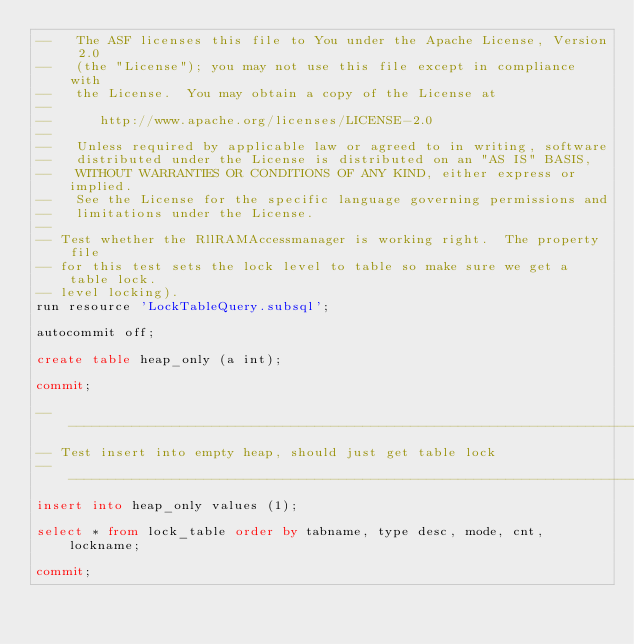Convert code to text. <code><loc_0><loc_0><loc_500><loc_500><_SQL_>--   The ASF licenses this file to You under the Apache License, Version 2.0
--   (the "License"); you may not use this file except in compliance with
--   the License.  You may obtain a copy of the License at
--
--      http://www.apache.org/licenses/LICENSE-2.0
--
--   Unless required by applicable law or agreed to in writing, software
--   distributed under the License is distributed on an "AS IS" BASIS,
--   WITHOUT WARRANTIES OR CONDITIONS OF ANY KIND, either express or implied.
--   See the License for the specific language governing permissions and
--   limitations under the License.
--
-- Test whether the RllRAMAccessmanager is working right.  The property file
-- for this test sets the lock level to table so make sure we get a table lock.
-- level locking). 
run resource 'LockTableQuery.subsql';

autocommit off;

create table heap_only (a int);

commit;

--------------------------------------------------------------------------------
-- Test insert into empty heap, should just get table lock 
--------------------------------------------------------------------------------
insert into heap_only values (1);

select * from lock_table order by tabname, type desc, mode, cnt, lockname;

commit;
</code> 